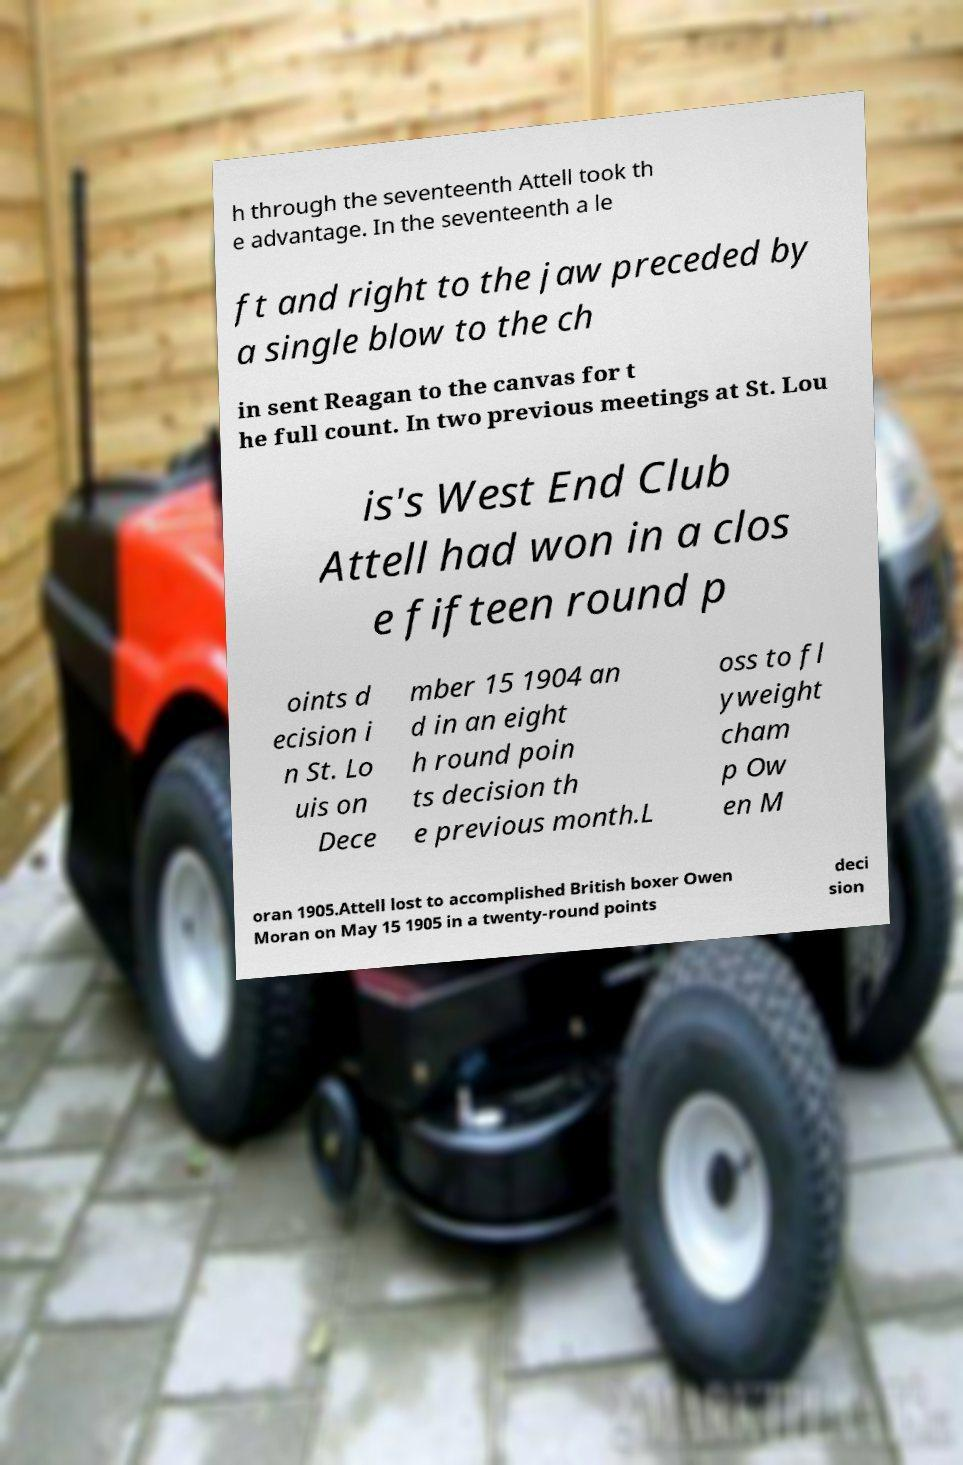What messages or text are displayed in this image? I need them in a readable, typed format. h through the seventeenth Attell took th e advantage. In the seventeenth a le ft and right to the jaw preceded by a single blow to the ch in sent Reagan to the canvas for t he full count. In two previous meetings at St. Lou is's West End Club Attell had won in a clos e fifteen round p oints d ecision i n St. Lo uis on Dece mber 15 1904 an d in an eight h round poin ts decision th e previous month.L oss to fl yweight cham p Ow en M oran 1905.Attell lost to accomplished British boxer Owen Moran on May 15 1905 in a twenty-round points deci sion 